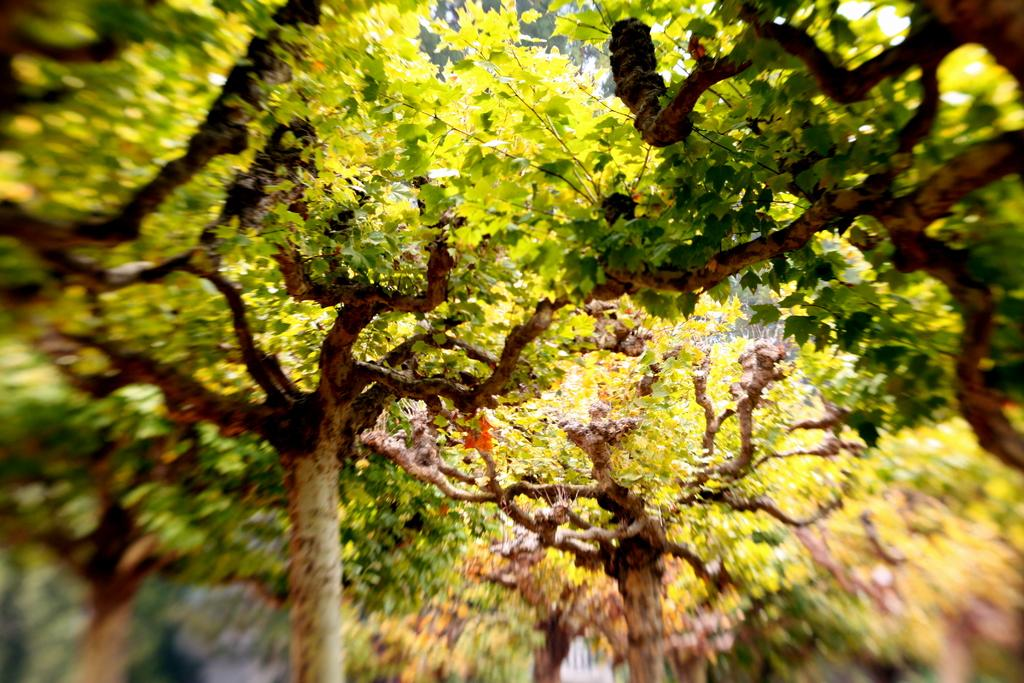What type of vegetation can be seen in the image? There are trees in the image. How are the trees depicted in the image? The trees are truncated in the image. What part of the image is blurred? The bottom of the image is blurred. What thoughts are expressed by the trees in the image? There are no thoughts expressed by the trees in the image, as trees do not have the ability to think or express thoughts. 